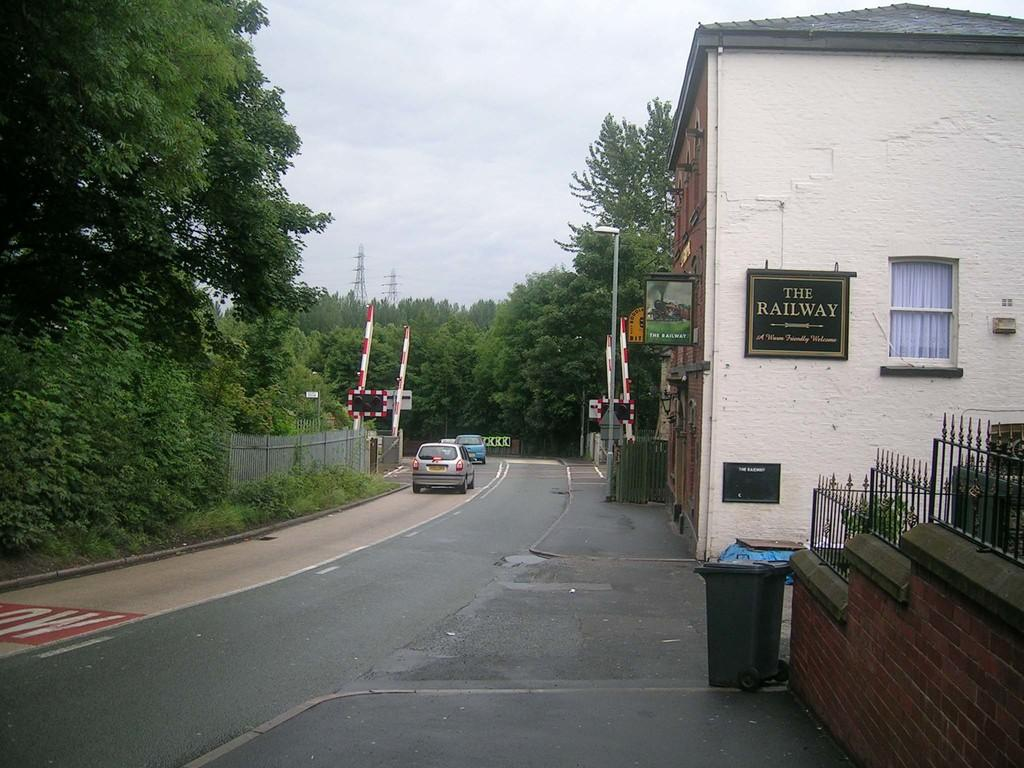<image>
Create a compact narrative representing the image presented. A street and next to it is a building with a sign on it calling it The Railway. 